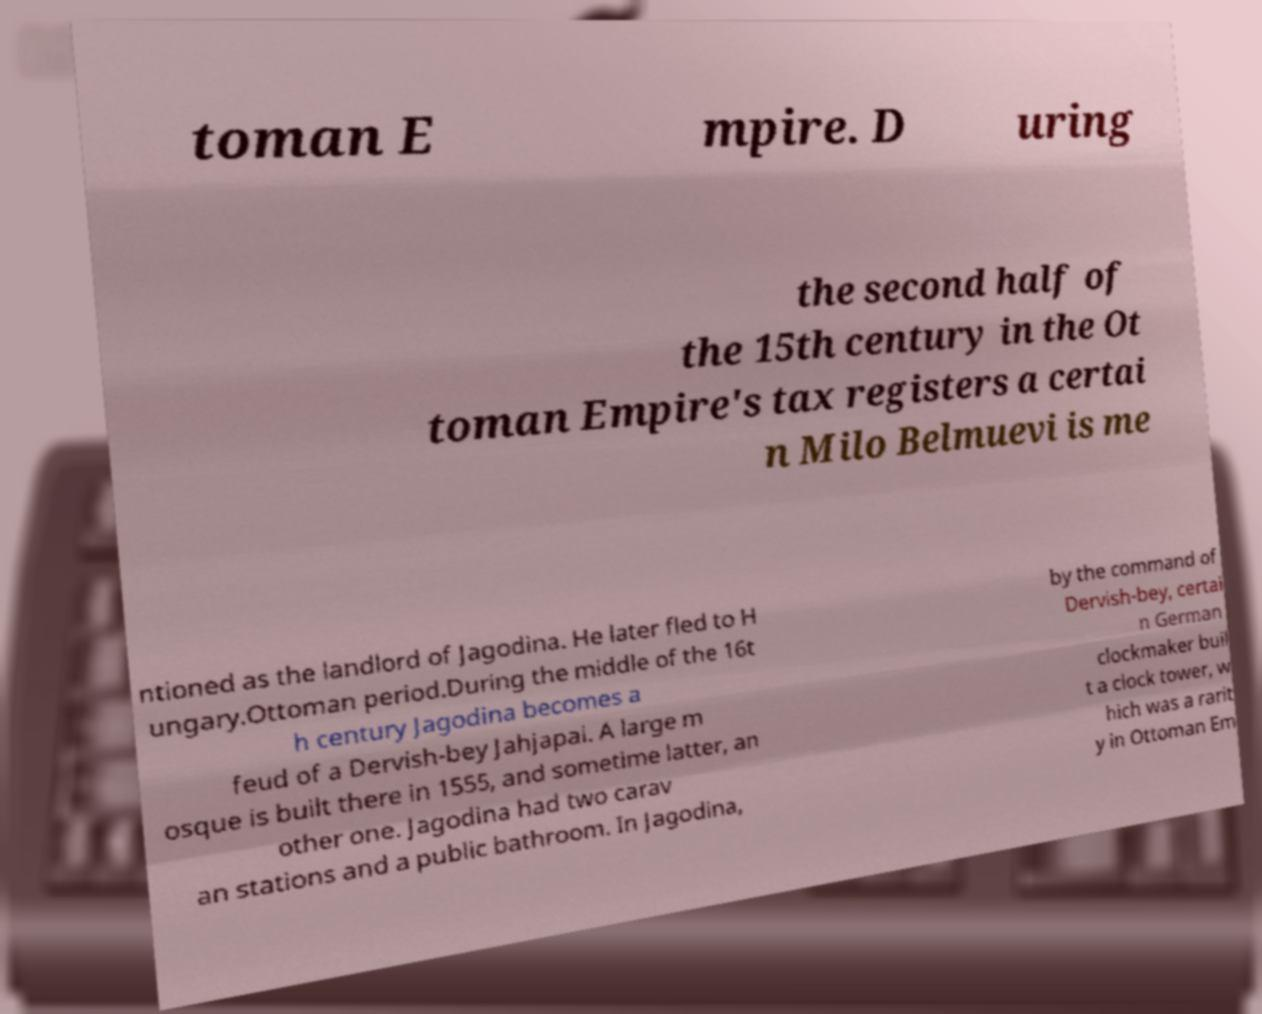For documentation purposes, I need the text within this image transcribed. Could you provide that? toman E mpire. D uring the second half of the 15th century in the Ot toman Empire's tax registers a certai n Milo Belmuevi is me ntioned as the landlord of Jagodina. He later fled to H ungary.Ottoman period.During the middle of the 16t h century Jagodina becomes a feud of a Dervish-bey Jahjapai. A large m osque is built there in 1555, and sometime latter, an other one. Jagodina had two carav an stations and a public bathroom. In Jagodina, by the command of Dervish-bey, certai n German clockmaker buil t a clock tower, w hich was a rarit y in Ottoman Em 